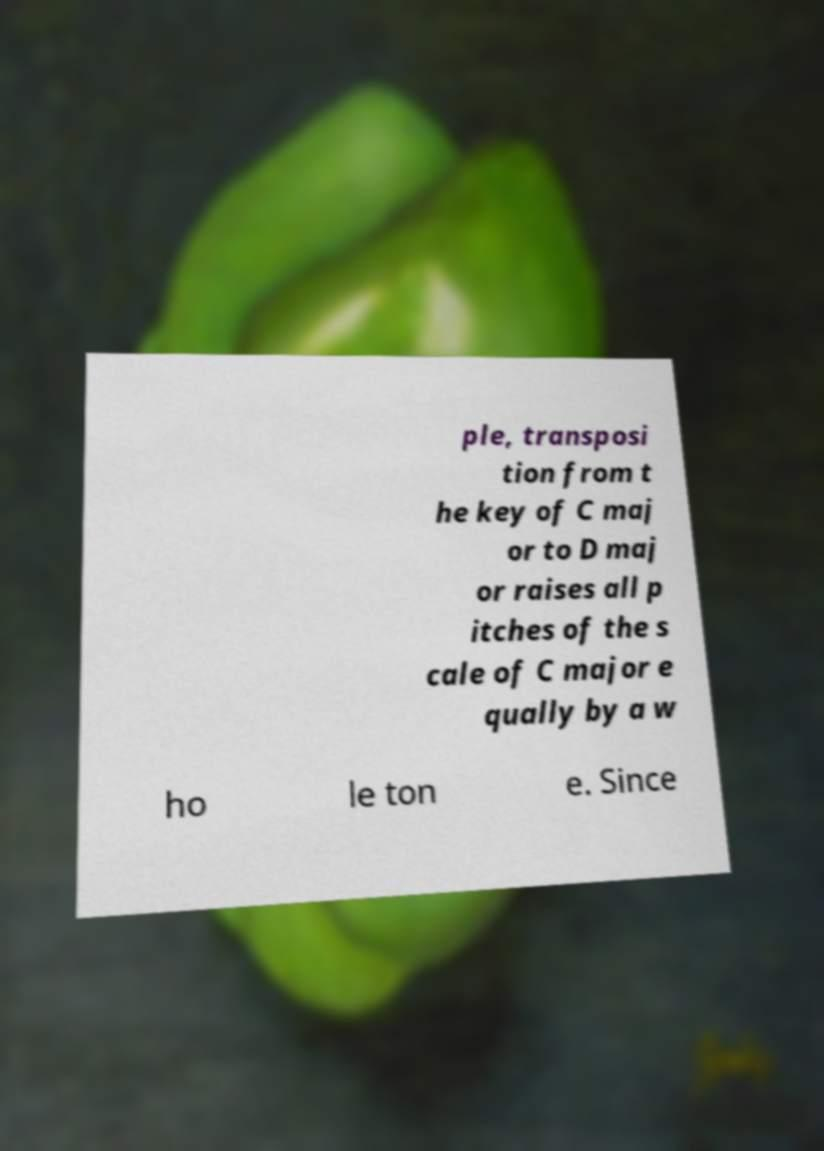Can you accurately transcribe the text from the provided image for me? ple, transposi tion from t he key of C maj or to D maj or raises all p itches of the s cale of C major e qually by a w ho le ton e. Since 